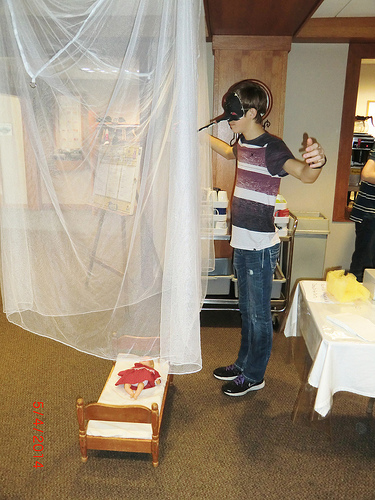<image>
Is there a curtain on the doll? No. The curtain is not positioned on the doll. They may be near each other, but the curtain is not supported by or resting on top of the doll. 